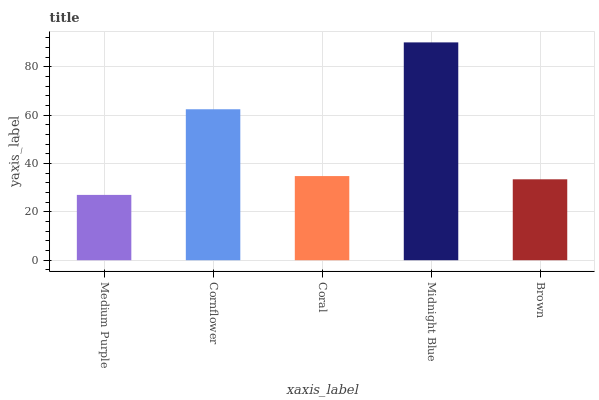Is Medium Purple the minimum?
Answer yes or no. Yes. Is Midnight Blue the maximum?
Answer yes or no. Yes. Is Cornflower the minimum?
Answer yes or no. No. Is Cornflower the maximum?
Answer yes or no. No. Is Cornflower greater than Medium Purple?
Answer yes or no. Yes. Is Medium Purple less than Cornflower?
Answer yes or no. Yes. Is Medium Purple greater than Cornflower?
Answer yes or no. No. Is Cornflower less than Medium Purple?
Answer yes or no. No. Is Coral the high median?
Answer yes or no. Yes. Is Coral the low median?
Answer yes or no. Yes. Is Brown the high median?
Answer yes or no. No. Is Midnight Blue the low median?
Answer yes or no. No. 